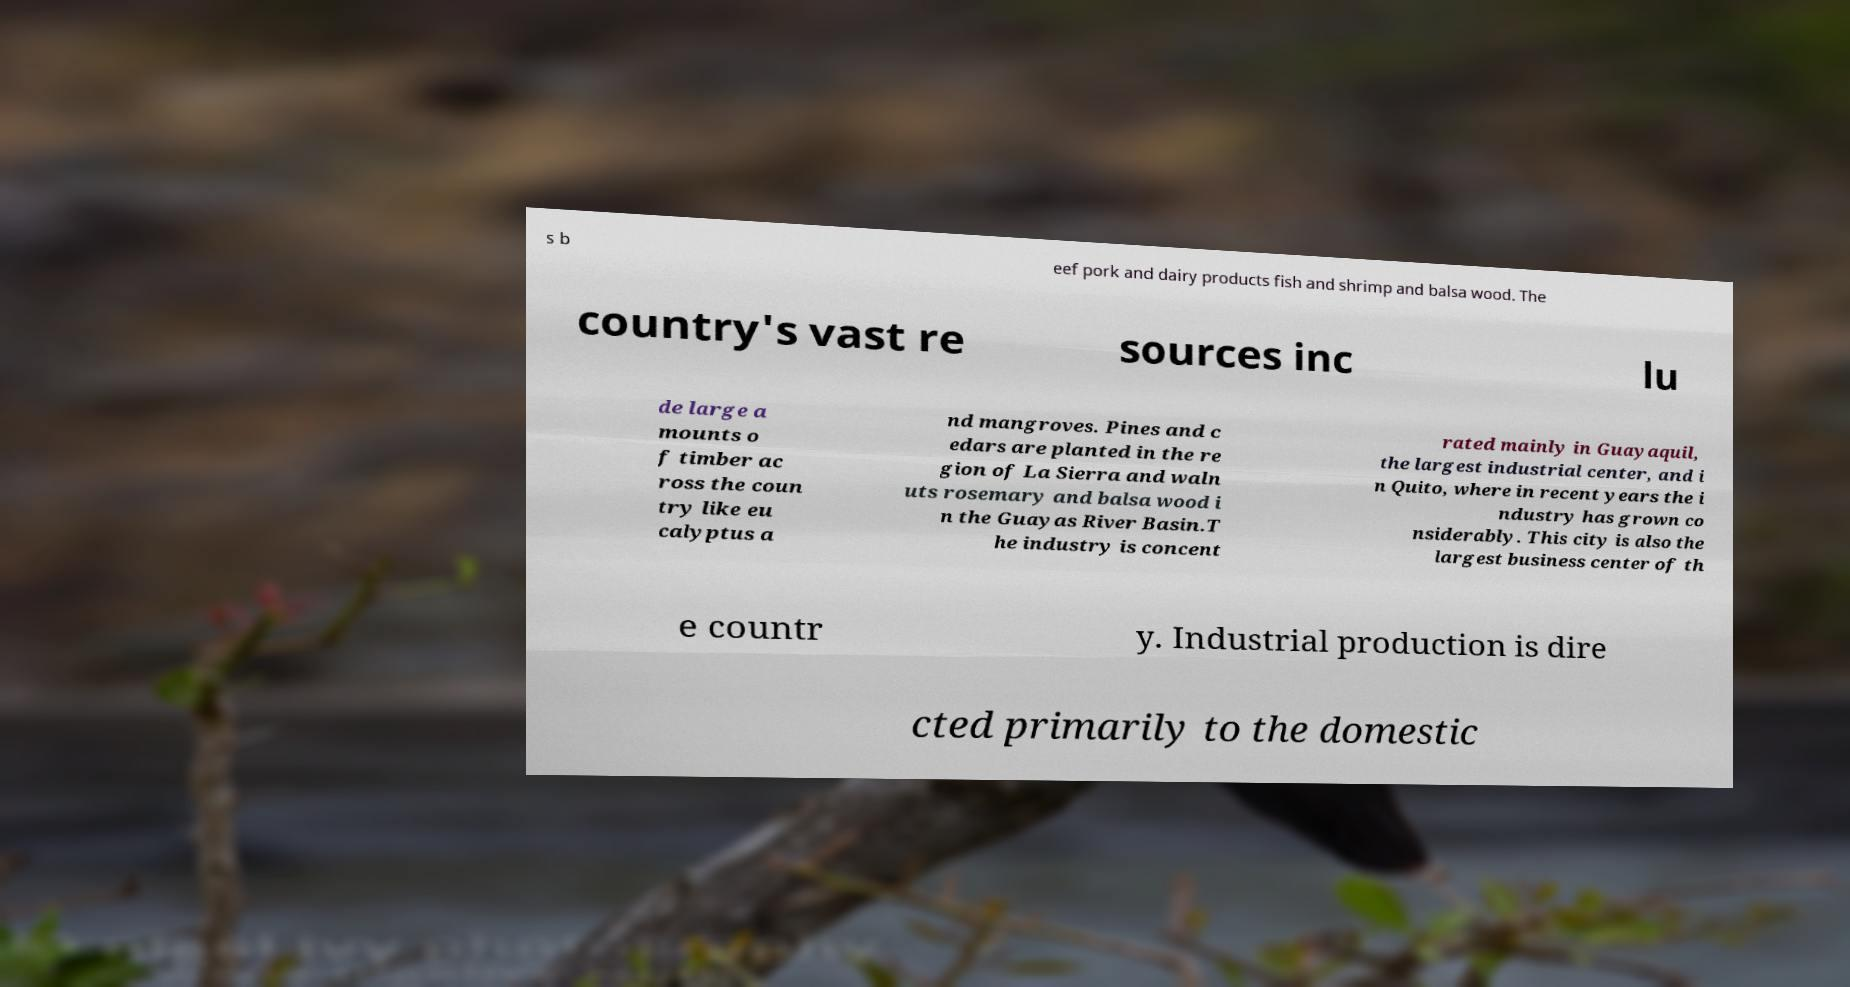What messages or text are displayed in this image? I need them in a readable, typed format. s b eef pork and dairy products fish and shrimp and balsa wood. The country's vast re sources inc lu de large a mounts o f timber ac ross the coun try like eu calyptus a nd mangroves. Pines and c edars are planted in the re gion of La Sierra and waln uts rosemary and balsa wood i n the Guayas River Basin.T he industry is concent rated mainly in Guayaquil, the largest industrial center, and i n Quito, where in recent years the i ndustry has grown co nsiderably. This city is also the largest business center of th e countr y. Industrial production is dire cted primarily to the domestic 